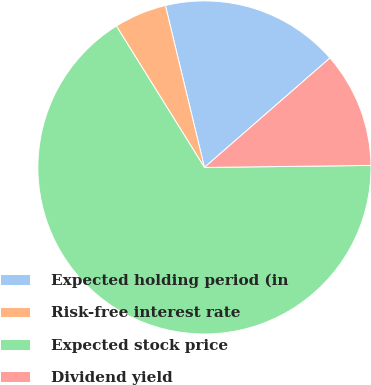Convert chart to OTSL. <chart><loc_0><loc_0><loc_500><loc_500><pie_chart><fcel>Expected holding period (in<fcel>Risk-free interest rate<fcel>Expected stock price<fcel>Dividend yield<nl><fcel>17.35%<fcel>5.1%<fcel>66.33%<fcel>11.22%<nl></chart> 